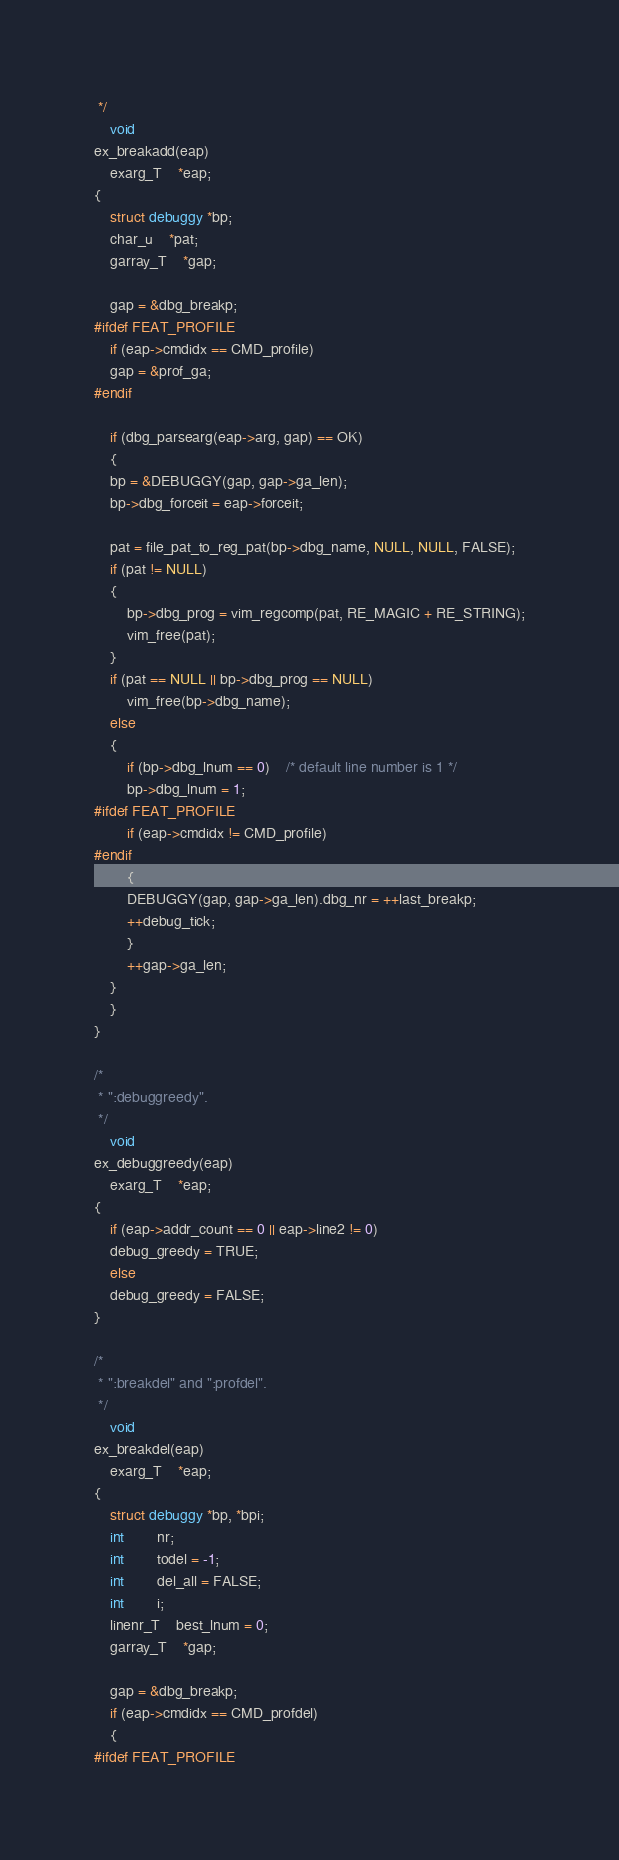Convert code to text. <code><loc_0><loc_0><loc_500><loc_500><_C_> */
    void
ex_breakadd(eap)
    exarg_T	*eap;
{
    struct debuggy *bp;
    char_u	*pat;
    garray_T	*gap;

    gap = &dbg_breakp;
#ifdef FEAT_PROFILE
    if (eap->cmdidx == CMD_profile)
	gap = &prof_ga;
#endif

    if (dbg_parsearg(eap->arg, gap) == OK)
    {
	bp = &DEBUGGY(gap, gap->ga_len);
	bp->dbg_forceit = eap->forceit;

	pat = file_pat_to_reg_pat(bp->dbg_name, NULL, NULL, FALSE);
	if (pat != NULL)
	{
	    bp->dbg_prog = vim_regcomp(pat, RE_MAGIC + RE_STRING);
	    vim_free(pat);
	}
	if (pat == NULL || bp->dbg_prog == NULL)
	    vim_free(bp->dbg_name);
	else
	{
	    if (bp->dbg_lnum == 0)	/* default line number is 1 */
		bp->dbg_lnum = 1;
#ifdef FEAT_PROFILE
	    if (eap->cmdidx != CMD_profile)
#endif
	    {
		DEBUGGY(gap, gap->ga_len).dbg_nr = ++last_breakp;
		++debug_tick;
	    }
	    ++gap->ga_len;
	}
    }
}

/*
 * ":debuggreedy".
 */
    void
ex_debuggreedy(eap)
    exarg_T	*eap;
{
    if (eap->addr_count == 0 || eap->line2 != 0)
	debug_greedy = TRUE;
    else
	debug_greedy = FALSE;
}

/*
 * ":breakdel" and ":profdel".
 */
    void
ex_breakdel(eap)
    exarg_T	*eap;
{
    struct debuggy *bp, *bpi;
    int		nr;
    int		todel = -1;
    int		del_all = FALSE;
    int		i;
    linenr_T	best_lnum = 0;
    garray_T	*gap;

    gap = &dbg_breakp;
    if (eap->cmdidx == CMD_profdel)
    {
#ifdef FEAT_PROFILE</code> 